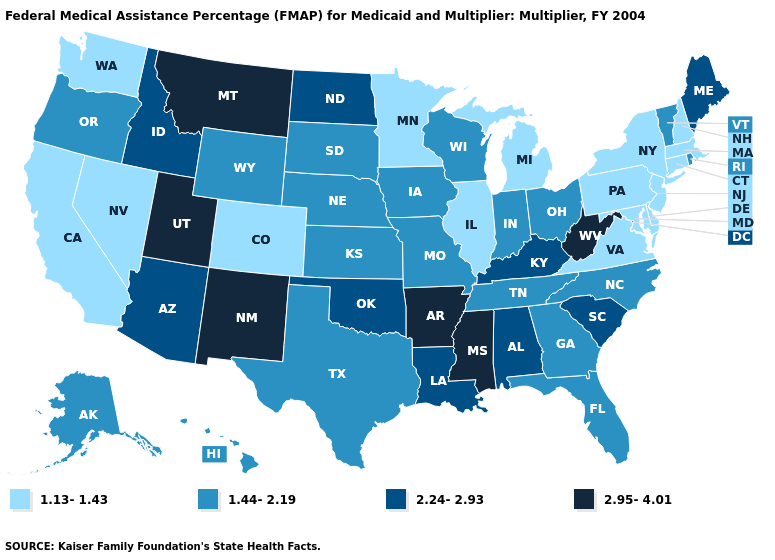Does Maine have the lowest value in the Northeast?
Write a very short answer. No. Name the states that have a value in the range 2.95-4.01?
Quick response, please. Arkansas, Mississippi, Montana, New Mexico, Utah, West Virginia. Which states hav the highest value in the Northeast?
Give a very brief answer. Maine. What is the value of Montana?
Write a very short answer. 2.95-4.01. Among the states that border Maryland , does West Virginia have the lowest value?
Concise answer only. No. What is the value of North Carolina?
Answer briefly. 1.44-2.19. Name the states that have a value in the range 1.13-1.43?
Write a very short answer. California, Colorado, Connecticut, Delaware, Illinois, Maryland, Massachusetts, Michigan, Minnesota, Nevada, New Hampshire, New Jersey, New York, Pennsylvania, Virginia, Washington. Which states have the highest value in the USA?
Short answer required. Arkansas, Mississippi, Montana, New Mexico, Utah, West Virginia. Among the states that border Tennessee , which have the highest value?
Short answer required. Arkansas, Mississippi. Name the states that have a value in the range 1.13-1.43?
Answer briefly. California, Colorado, Connecticut, Delaware, Illinois, Maryland, Massachusetts, Michigan, Minnesota, Nevada, New Hampshire, New Jersey, New York, Pennsylvania, Virginia, Washington. Does Maryland have the lowest value in the USA?
Short answer required. Yes. Which states hav the highest value in the Northeast?
Give a very brief answer. Maine. Is the legend a continuous bar?
Quick response, please. No. What is the lowest value in states that border Vermont?
Quick response, please. 1.13-1.43. Does the map have missing data?
Be succinct. No. 